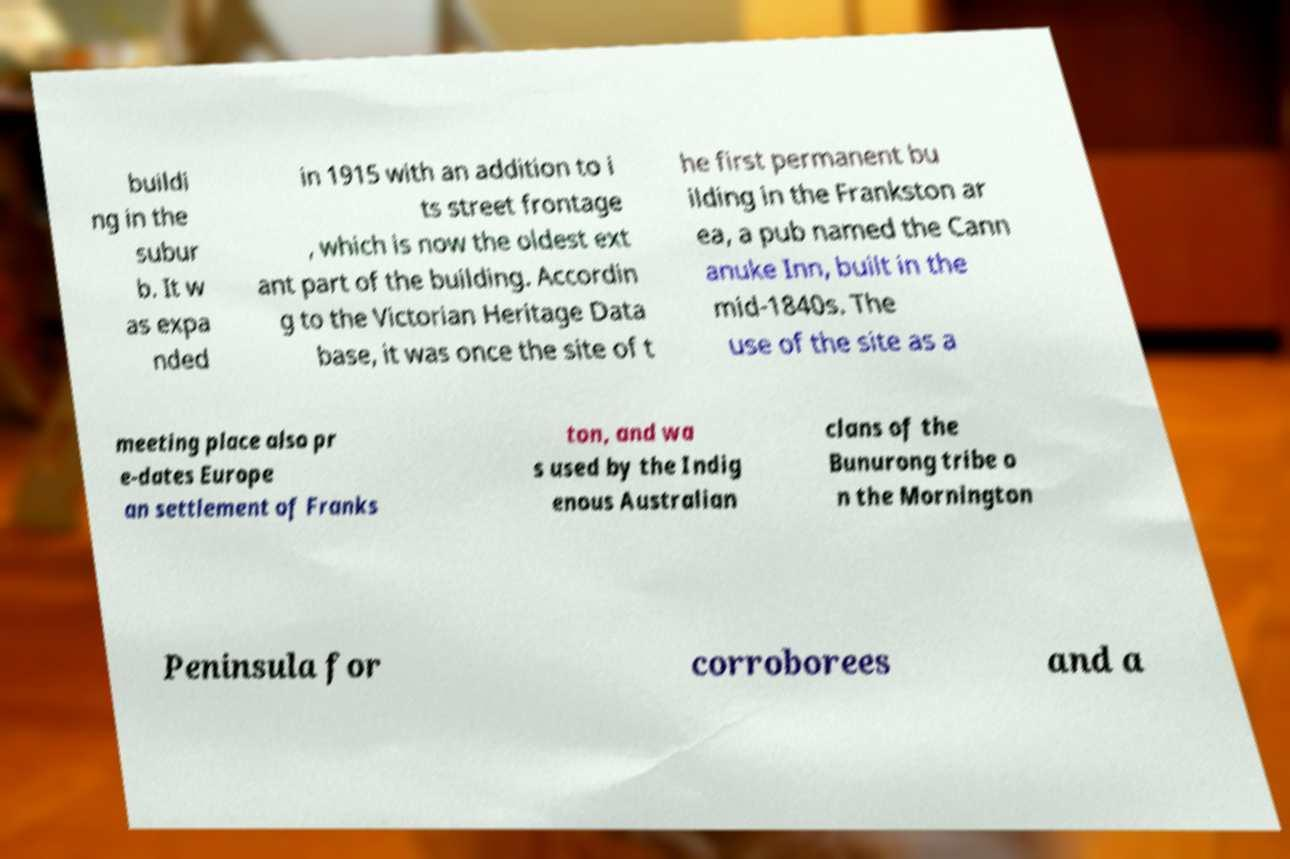Can you read and provide the text displayed in the image?This photo seems to have some interesting text. Can you extract and type it out for me? buildi ng in the subur b. It w as expa nded in 1915 with an addition to i ts street frontage , which is now the oldest ext ant part of the building. Accordin g to the Victorian Heritage Data base, it was once the site of t he first permanent bu ilding in the Frankston ar ea, a pub named the Cann anuke Inn, built in the mid-1840s. The use of the site as a meeting place also pr e-dates Europe an settlement of Franks ton, and wa s used by the Indig enous Australian clans of the Bunurong tribe o n the Mornington Peninsula for corroborees and a 